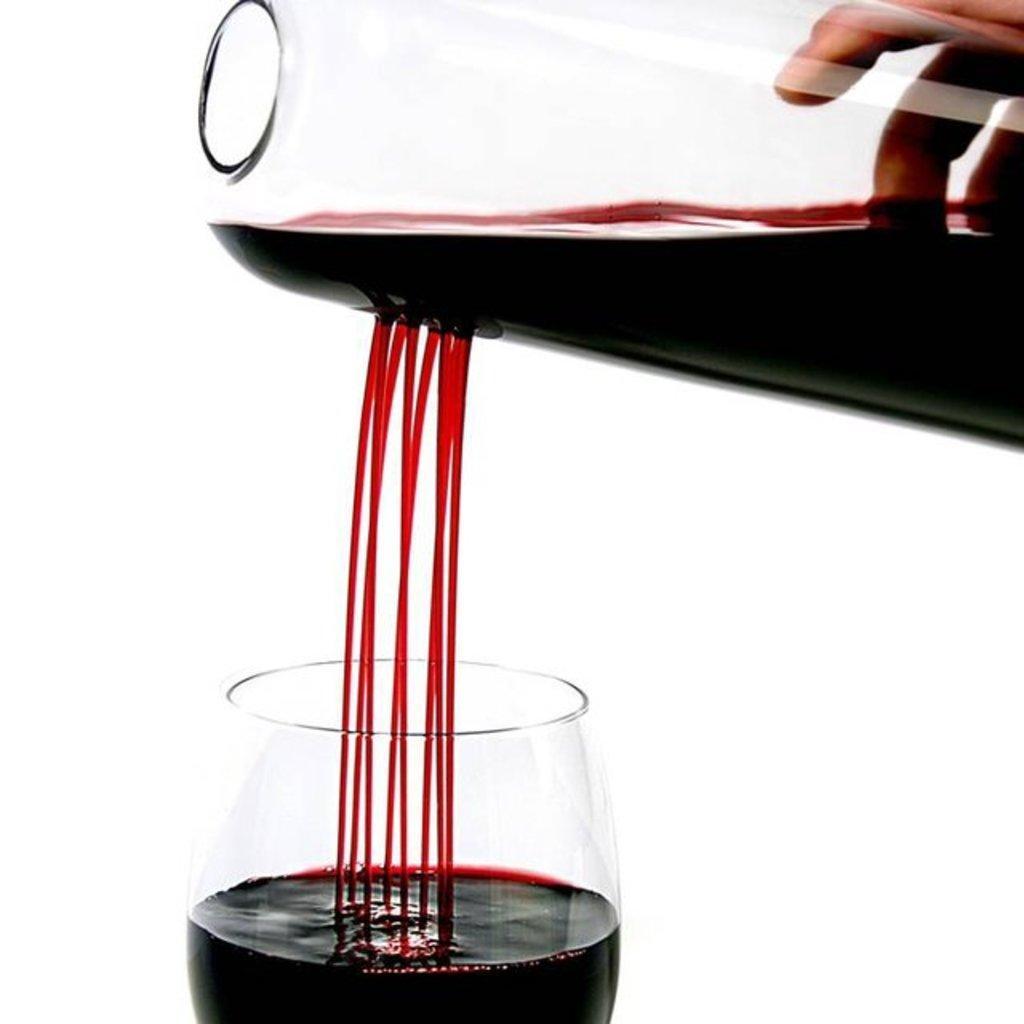Could you give a brief overview of what you see in this image? Here in this picture we can see a person's hand pouring red wine through a jar in the glass present below it over there. 